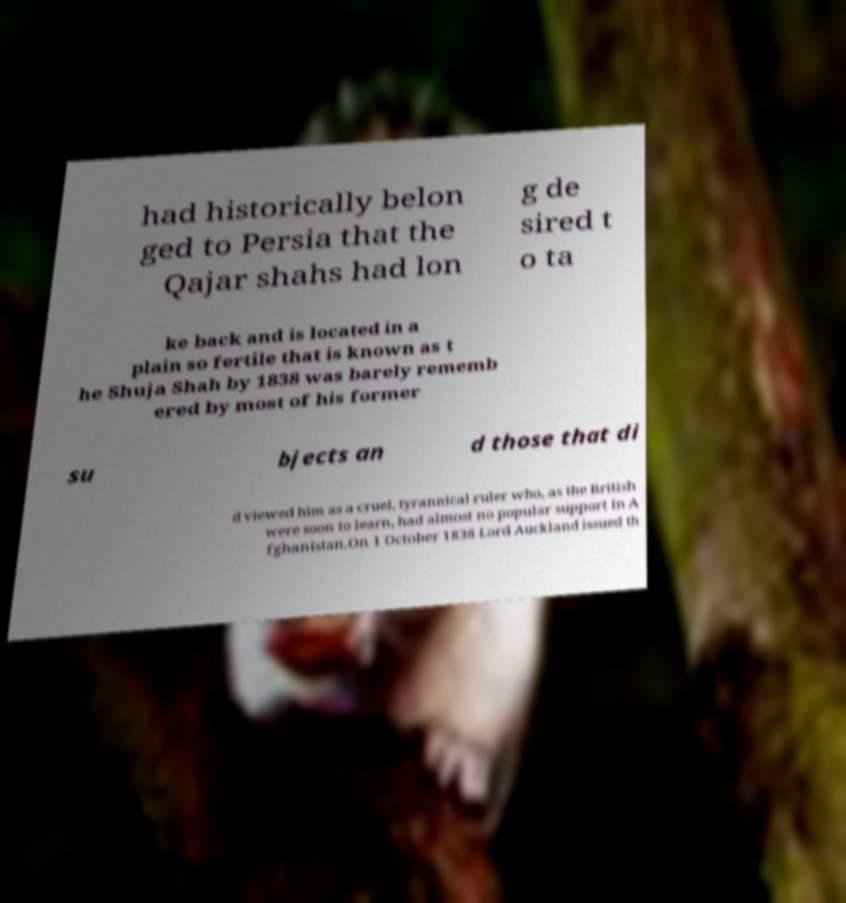Can you read and provide the text displayed in the image?This photo seems to have some interesting text. Can you extract and type it out for me? had historically belon ged to Persia that the Qajar shahs had lon g de sired t o ta ke back and is located in a plain so fertile that is known as t he Shuja Shah by 1838 was barely rememb ered by most of his former su bjects an d those that di d viewed him as a cruel, tyrannical ruler who, as the British were soon to learn, had almost no popular support in A fghanistan.On 1 October 1838 Lord Auckland issued th 